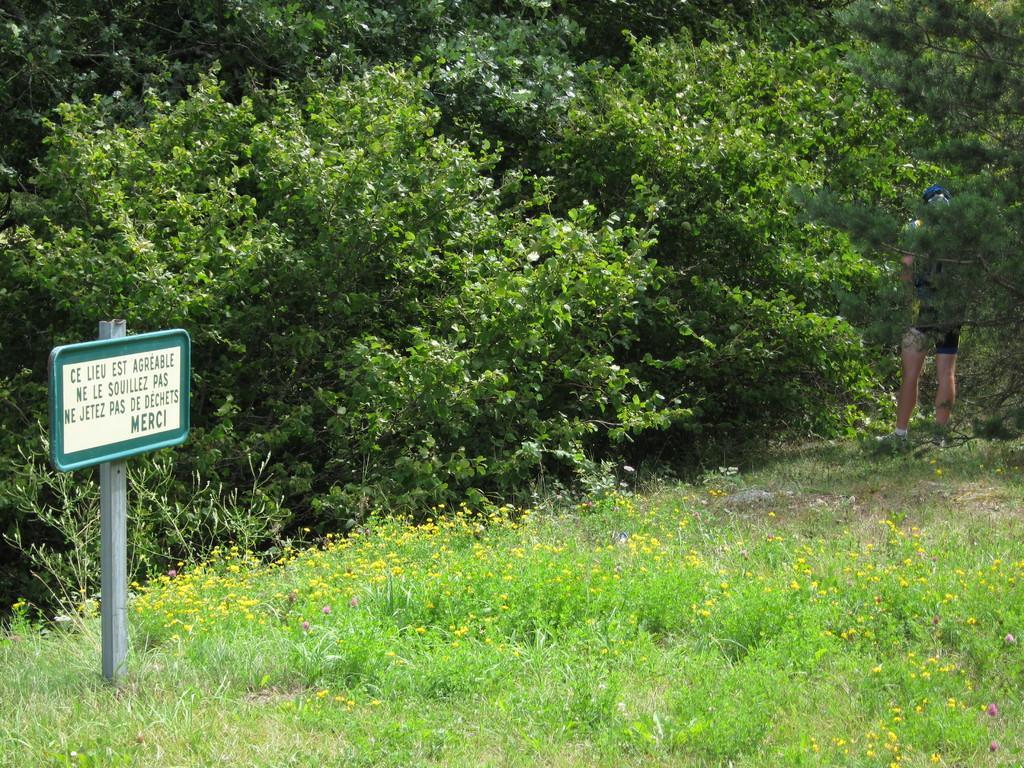Please provide a concise description of this image. In this picture I can see the grass and few flowers in front. I can also see a board, on which there is something in written. In the background I can see the trees. On the right side of this picture, I can see a person standing. 